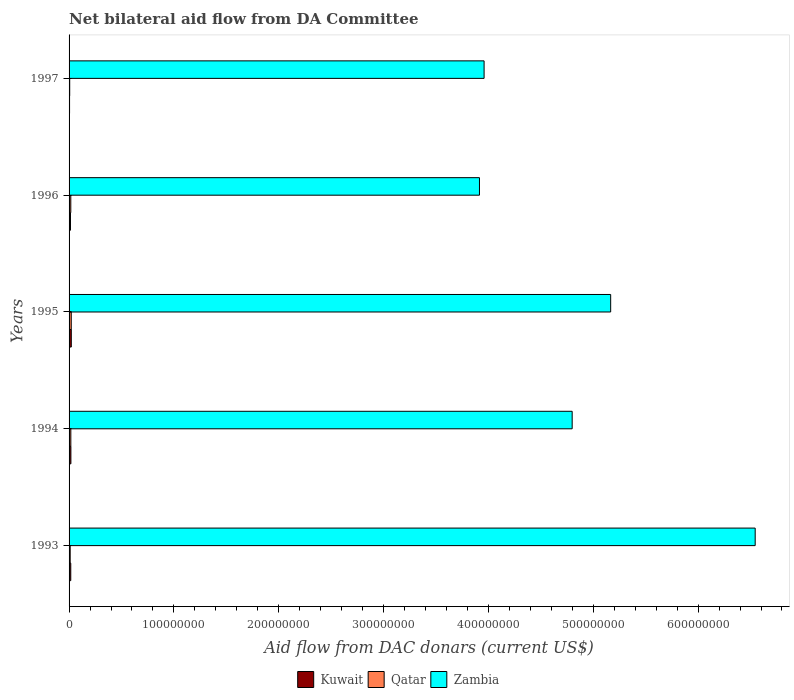How many different coloured bars are there?
Make the answer very short. 3. How many groups of bars are there?
Your response must be concise. 5. Are the number of bars per tick equal to the number of legend labels?
Your answer should be compact. Yes. Are the number of bars on each tick of the Y-axis equal?
Keep it short and to the point. Yes. How many bars are there on the 2nd tick from the top?
Provide a short and direct response. 3. What is the aid flow in in Kuwait in 1994?
Your answer should be very brief. 1.73e+06. Across all years, what is the maximum aid flow in in Qatar?
Your answer should be compact. 2.08e+06. Across all years, what is the minimum aid flow in in Zambia?
Ensure brevity in your answer.  3.91e+08. In which year was the aid flow in in Kuwait maximum?
Provide a short and direct response. 1995. What is the total aid flow in in Zambia in the graph?
Your answer should be very brief. 2.44e+09. What is the difference between the aid flow in in Kuwait in 1994 and that in 1997?
Offer a terse response. 1.26e+06. What is the difference between the aid flow in in Qatar in 1996 and the aid flow in in Kuwait in 1995?
Ensure brevity in your answer.  -4.80e+05. What is the average aid flow in in Qatar per year?
Make the answer very short. 1.41e+06. In the year 1994, what is the difference between the aid flow in in Kuwait and aid flow in in Zambia?
Your answer should be compact. -4.78e+08. In how many years, is the aid flow in in Qatar greater than 200000000 US$?
Offer a terse response. 0. What is the ratio of the aid flow in in Kuwait in 1994 to that in 1995?
Ensure brevity in your answer.  0.82. Is the aid flow in in Kuwait in 1994 less than that in 1996?
Keep it short and to the point. No. What is the difference between the highest and the lowest aid flow in in Kuwait?
Your response must be concise. 1.65e+06. What does the 1st bar from the top in 1993 represents?
Your response must be concise. Zambia. What does the 1st bar from the bottom in 1997 represents?
Provide a short and direct response. Kuwait. Is it the case that in every year, the sum of the aid flow in in Kuwait and aid flow in in Zambia is greater than the aid flow in in Qatar?
Ensure brevity in your answer.  Yes. Are all the bars in the graph horizontal?
Your answer should be compact. Yes. What is the difference between two consecutive major ticks on the X-axis?
Provide a succinct answer. 1.00e+08. Are the values on the major ticks of X-axis written in scientific E-notation?
Your response must be concise. No. Does the graph contain any zero values?
Make the answer very short. No. Does the graph contain grids?
Give a very brief answer. No. What is the title of the graph?
Ensure brevity in your answer.  Net bilateral aid flow from DA Committee. What is the label or title of the X-axis?
Keep it short and to the point. Aid flow from DAC donars (current US$). What is the label or title of the Y-axis?
Make the answer very short. Years. What is the Aid flow from DAC donars (current US$) of Kuwait in 1993?
Your answer should be compact. 1.62e+06. What is the Aid flow from DAC donars (current US$) of Qatar in 1993?
Offer a very short reply. 1.07e+06. What is the Aid flow from DAC donars (current US$) of Zambia in 1993?
Offer a terse response. 6.54e+08. What is the Aid flow from DAC donars (current US$) in Kuwait in 1994?
Offer a very short reply. 1.73e+06. What is the Aid flow from DAC donars (current US$) of Qatar in 1994?
Your answer should be compact. 1.68e+06. What is the Aid flow from DAC donars (current US$) of Zambia in 1994?
Offer a very short reply. 4.80e+08. What is the Aid flow from DAC donars (current US$) in Kuwait in 1995?
Provide a succinct answer. 2.12e+06. What is the Aid flow from DAC donars (current US$) in Qatar in 1995?
Your response must be concise. 2.08e+06. What is the Aid flow from DAC donars (current US$) of Zambia in 1995?
Keep it short and to the point. 5.17e+08. What is the Aid flow from DAC donars (current US$) of Kuwait in 1996?
Your answer should be very brief. 1.35e+06. What is the Aid flow from DAC donars (current US$) in Qatar in 1996?
Give a very brief answer. 1.64e+06. What is the Aid flow from DAC donars (current US$) of Zambia in 1996?
Your response must be concise. 3.91e+08. What is the Aid flow from DAC donars (current US$) of Kuwait in 1997?
Give a very brief answer. 4.70e+05. What is the Aid flow from DAC donars (current US$) of Zambia in 1997?
Keep it short and to the point. 3.96e+08. Across all years, what is the maximum Aid flow from DAC donars (current US$) in Kuwait?
Your answer should be very brief. 2.12e+06. Across all years, what is the maximum Aid flow from DAC donars (current US$) in Qatar?
Your answer should be very brief. 2.08e+06. Across all years, what is the maximum Aid flow from DAC donars (current US$) in Zambia?
Give a very brief answer. 6.54e+08. Across all years, what is the minimum Aid flow from DAC donars (current US$) in Qatar?
Offer a very short reply. 6.00e+05. Across all years, what is the minimum Aid flow from DAC donars (current US$) in Zambia?
Offer a terse response. 3.91e+08. What is the total Aid flow from DAC donars (current US$) of Kuwait in the graph?
Provide a short and direct response. 7.29e+06. What is the total Aid flow from DAC donars (current US$) of Qatar in the graph?
Ensure brevity in your answer.  7.07e+06. What is the total Aid flow from DAC donars (current US$) of Zambia in the graph?
Provide a succinct answer. 2.44e+09. What is the difference between the Aid flow from DAC donars (current US$) of Kuwait in 1993 and that in 1994?
Provide a short and direct response. -1.10e+05. What is the difference between the Aid flow from DAC donars (current US$) in Qatar in 1993 and that in 1994?
Ensure brevity in your answer.  -6.10e+05. What is the difference between the Aid flow from DAC donars (current US$) of Zambia in 1993 and that in 1994?
Make the answer very short. 1.75e+08. What is the difference between the Aid flow from DAC donars (current US$) of Kuwait in 1993 and that in 1995?
Your response must be concise. -5.00e+05. What is the difference between the Aid flow from DAC donars (current US$) of Qatar in 1993 and that in 1995?
Provide a succinct answer. -1.01e+06. What is the difference between the Aid flow from DAC donars (current US$) in Zambia in 1993 and that in 1995?
Make the answer very short. 1.38e+08. What is the difference between the Aid flow from DAC donars (current US$) of Kuwait in 1993 and that in 1996?
Your response must be concise. 2.70e+05. What is the difference between the Aid flow from DAC donars (current US$) of Qatar in 1993 and that in 1996?
Ensure brevity in your answer.  -5.70e+05. What is the difference between the Aid flow from DAC donars (current US$) of Zambia in 1993 and that in 1996?
Provide a succinct answer. 2.63e+08. What is the difference between the Aid flow from DAC donars (current US$) of Kuwait in 1993 and that in 1997?
Your answer should be very brief. 1.15e+06. What is the difference between the Aid flow from DAC donars (current US$) of Qatar in 1993 and that in 1997?
Give a very brief answer. 4.70e+05. What is the difference between the Aid flow from DAC donars (current US$) of Zambia in 1993 and that in 1997?
Keep it short and to the point. 2.59e+08. What is the difference between the Aid flow from DAC donars (current US$) in Kuwait in 1994 and that in 1995?
Your answer should be compact. -3.90e+05. What is the difference between the Aid flow from DAC donars (current US$) of Qatar in 1994 and that in 1995?
Give a very brief answer. -4.00e+05. What is the difference between the Aid flow from DAC donars (current US$) in Zambia in 1994 and that in 1995?
Keep it short and to the point. -3.67e+07. What is the difference between the Aid flow from DAC donars (current US$) of Kuwait in 1994 and that in 1996?
Ensure brevity in your answer.  3.80e+05. What is the difference between the Aid flow from DAC donars (current US$) of Zambia in 1994 and that in 1996?
Your response must be concise. 8.84e+07. What is the difference between the Aid flow from DAC donars (current US$) in Kuwait in 1994 and that in 1997?
Your response must be concise. 1.26e+06. What is the difference between the Aid flow from DAC donars (current US$) in Qatar in 1994 and that in 1997?
Ensure brevity in your answer.  1.08e+06. What is the difference between the Aid flow from DAC donars (current US$) of Zambia in 1994 and that in 1997?
Ensure brevity in your answer.  8.40e+07. What is the difference between the Aid flow from DAC donars (current US$) of Kuwait in 1995 and that in 1996?
Your response must be concise. 7.70e+05. What is the difference between the Aid flow from DAC donars (current US$) of Zambia in 1995 and that in 1996?
Make the answer very short. 1.25e+08. What is the difference between the Aid flow from DAC donars (current US$) in Kuwait in 1995 and that in 1997?
Provide a succinct answer. 1.65e+06. What is the difference between the Aid flow from DAC donars (current US$) of Qatar in 1995 and that in 1997?
Offer a terse response. 1.48e+06. What is the difference between the Aid flow from DAC donars (current US$) of Zambia in 1995 and that in 1997?
Keep it short and to the point. 1.21e+08. What is the difference between the Aid flow from DAC donars (current US$) in Kuwait in 1996 and that in 1997?
Offer a very short reply. 8.80e+05. What is the difference between the Aid flow from DAC donars (current US$) of Qatar in 1996 and that in 1997?
Keep it short and to the point. 1.04e+06. What is the difference between the Aid flow from DAC donars (current US$) in Zambia in 1996 and that in 1997?
Ensure brevity in your answer.  -4.41e+06. What is the difference between the Aid flow from DAC donars (current US$) of Kuwait in 1993 and the Aid flow from DAC donars (current US$) of Zambia in 1994?
Your response must be concise. -4.78e+08. What is the difference between the Aid flow from DAC donars (current US$) in Qatar in 1993 and the Aid flow from DAC donars (current US$) in Zambia in 1994?
Provide a short and direct response. -4.79e+08. What is the difference between the Aid flow from DAC donars (current US$) of Kuwait in 1993 and the Aid flow from DAC donars (current US$) of Qatar in 1995?
Ensure brevity in your answer.  -4.60e+05. What is the difference between the Aid flow from DAC donars (current US$) in Kuwait in 1993 and the Aid flow from DAC donars (current US$) in Zambia in 1995?
Your answer should be compact. -5.15e+08. What is the difference between the Aid flow from DAC donars (current US$) in Qatar in 1993 and the Aid flow from DAC donars (current US$) in Zambia in 1995?
Your answer should be very brief. -5.16e+08. What is the difference between the Aid flow from DAC donars (current US$) in Kuwait in 1993 and the Aid flow from DAC donars (current US$) in Zambia in 1996?
Give a very brief answer. -3.90e+08. What is the difference between the Aid flow from DAC donars (current US$) of Qatar in 1993 and the Aid flow from DAC donars (current US$) of Zambia in 1996?
Your answer should be compact. -3.90e+08. What is the difference between the Aid flow from DAC donars (current US$) in Kuwait in 1993 and the Aid flow from DAC donars (current US$) in Qatar in 1997?
Offer a very short reply. 1.02e+06. What is the difference between the Aid flow from DAC donars (current US$) of Kuwait in 1993 and the Aid flow from DAC donars (current US$) of Zambia in 1997?
Your answer should be compact. -3.94e+08. What is the difference between the Aid flow from DAC donars (current US$) in Qatar in 1993 and the Aid flow from DAC donars (current US$) in Zambia in 1997?
Your answer should be compact. -3.95e+08. What is the difference between the Aid flow from DAC donars (current US$) in Kuwait in 1994 and the Aid flow from DAC donars (current US$) in Qatar in 1995?
Keep it short and to the point. -3.50e+05. What is the difference between the Aid flow from DAC donars (current US$) in Kuwait in 1994 and the Aid flow from DAC donars (current US$) in Zambia in 1995?
Your response must be concise. -5.15e+08. What is the difference between the Aid flow from DAC donars (current US$) in Qatar in 1994 and the Aid flow from DAC donars (current US$) in Zambia in 1995?
Your answer should be compact. -5.15e+08. What is the difference between the Aid flow from DAC donars (current US$) in Kuwait in 1994 and the Aid flow from DAC donars (current US$) in Zambia in 1996?
Provide a succinct answer. -3.90e+08. What is the difference between the Aid flow from DAC donars (current US$) of Qatar in 1994 and the Aid flow from DAC donars (current US$) of Zambia in 1996?
Keep it short and to the point. -3.90e+08. What is the difference between the Aid flow from DAC donars (current US$) in Kuwait in 1994 and the Aid flow from DAC donars (current US$) in Qatar in 1997?
Your answer should be very brief. 1.13e+06. What is the difference between the Aid flow from DAC donars (current US$) of Kuwait in 1994 and the Aid flow from DAC donars (current US$) of Zambia in 1997?
Your answer should be very brief. -3.94e+08. What is the difference between the Aid flow from DAC donars (current US$) in Qatar in 1994 and the Aid flow from DAC donars (current US$) in Zambia in 1997?
Make the answer very short. -3.94e+08. What is the difference between the Aid flow from DAC donars (current US$) of Kuwait in 1995 and the Aid flow from DAC donars (current US$) of Zambia in 1996?
Offer a terse response. -3.89e+08. What is the difference between the Aid flow from DAC donars (current US$) in Qatar in 1995 and the Aid flow from DAC donars (current US$) in Zambia in 1996?
Give a very brief answer. -3.89e+08. What is the difference between the Aid flow from DAC donars (current US$) of Kuwait in 1995 and the Aid flow from DAC donars (current US$) of Qatar in 1997?
Provide a succinct answer. 1.52e+06. What is the difference between the Aid flow from DAC donars (current US$) in Kuwait in 1995 and the Aid flow from DAC donars (current US$) in Zambia in 1997?
Provide a short and direct response. -3.94e+08. What is the difference between the Aid flow from DAC donars (current US$) in Qatar in 1995 and the Aid flow from DAC donars (current US$) in Zambia in 1997?
Your answer should be compact. -3.94e+08. What is the difference between the Aid flow from DAC donars (current US$) of Kuwait in 1996 and the Aid flow from DAC donars (current US$) of Qatar in 1997?
Offer a very short reply. 7.50e+05. What is the difference between the Aid flow from DAC donars (current US$) of Kuwait in 1996 and the Aid flow from DAC donars (current US$) of Zambia in 1997?
Ensure brevity in your answer.  -3.95e+08. What is the difference between the Aid flow from DAC donars (current US$) of Qatar in 1996 and the Aid flow from DAC donars (current US$) of Zambia in 1997?
Offer a very short reply. -3.94e+08. What is the average Aid flow from DAC donars (current US$) of Kuwait per year?
Your answer should be very brief. 1.46e+06. What is the average Aid flow from DAC donars (current US$) of Qatar per year?
Offer a terse response. 1.41e+06. What is the average Aid flow from DAC donars (current US$) of Zambia per year?
Your answer should be very brief. 4.88e+08. In the year 1993, what is the difference between the Aid flow from DAC donars (current US$) in Kuwait and Aid flow from DAC donars (current US$) in Qatar?
Offer a terse response. 5.50e+05. In the year 1993, what is the difference between the Aid flow from DAC donars (current US$) of Kuwait and Aid flow from DAC donars (current US$) of Zambia?
Provide a short and direct response. -6.53e+08. In the year 1993, what is the difference between the Aid flow from DAC donars (current US$) in Qatar and Aid flow from DAC donars (current US$) in Zambia?
Offer a terse response. -6.53e+08. In the year 1994, what is the difference between the Aid flow from DAC donars (current US$) of Kuwait and Aid flow from DAC donars (current US$) of Zambia?
Offer a very short reply. -4.78e+08. In the year 1994, what is the difference between the Aid flow from DAC donars (current US$) in Qatar and Aid flow from DAC donars (current US$) in Zambia?
Offer a terse response. -4.78e+08. In the year 1995, what is the difference between the Aid flow from DAC donars (current US$) of Kuwait and Aid flow from DAC donars (current US$) of Qatar?
Offer a terse response. 4.00e+04. In the year 1995, what is the difference between the Aid flow from DAC donars (current US$) of Kuwait and Aid flow from DAC donars (current US$) of Zambia?
Your answer should be compact. -5.14e+08. In the year 1995, what is the difference between the Aid flow from DAC donars (current US$) of Qatar and Aid flow from DAC donars (current US$) of Zambia?
Provide a short and direct response. -5.15e+08. In the year 1996, what is the difference between the Aid flow from DAC donars (current US$) in Kuwait and Aid flow from DAC donars (current US$) in Qatar?
Give a very brief answer. -2.90e+05. In the year 1996, what is the difference between the Aid flow from DAC donars (current US$) of Kuwait and Aid flow from DAC donars (current US$) of Zambia?
Your response must be concise. -3.90e+08. In the year 1996, what is the difference between the Aid flow from DAC donars (current US$) in Qatar and Aid flow from DAC donars (current US$) in Zambia?
Provide a succinct answer. -3.90e+08. In the year 1997, what is the difference between the Aid flow from DAC donars (current US$) in Kuwait and Aid flow from DAC donars (current US$) in Zambia?
Offer a very short reply. -3.95e+08. In the year 1997, what is the difference between the Aid flow from DAC donars (current US$) in Qatar and Aid flow from DAC donars (current US$) in Zambia?
Your response must be concise. -3.95e+08. What is the ratio of the Aid flow from DAC donars (current US$) in Kuwait in 1993 to that in 1994?
Ensure brevity in your answer.  0.94. What is the ratio of the Aid flow from DAC donars (current US$) of Qatar in 1993 to that in 1994?
Your response must be concise. 0.64. What is the ratio of the Aid flow from DAC donars (current US$) of Zambia in 1993 to that in 1994?
Make the answer very short. 1.36. What is the ratio of the Aid flow from DAC donars (current US$) of Kuwait in 1993 to that in 1995?
Make the answer very short. 0.76. What is the ratio of the Aid flow from DAC donars (current US$) in Qatar in 1993 to that in 1995?
Give a very brief answer. 0.51. What is the ratio of the Aid flow from DAC donars (current US$) in Zambia in 1993 to that in 1995?
Keep it short and to the point. 1.27. What is the ratio of the Aid flow from DAC donars (current US$) of Qatar in 1993 to that in 1996?
Offer a terse response. 0.65. What is the ratio of the Aid flow from DAC donars (current US$) in Zambia in 1993 to that in 1996?
Provide a succinct answer. 1.67. What is the ratio of the Aid flow from DAC donars (current US$) in Kuwait in 1993 to that in 1997?
Ensure brevity in your answer.  3.45. What is the ratio of the Aid flow from DAC donars (current US$) in Qatar in 1993 to that in 1997?
Ensure brevity in your answer.  1.78. What is the ratio of the Aid flow from DAC donars (current US$) of Zambia in 1993 to that in 1997?
Offer a terse response. 1.65. What is the ratio of the Aid flow from DAC donars (current US$) in Kuwait in 1994 to that in 1995?
Keep it short and to the point. 0.82. What is the ratio of the Aid flow from DAC donars (current US$) of Qatar in 1994 to that in 1995?
Provide a short and direct response. 0.81. What is the ratio of the Aid flow from DAC donars (current US$) of Zambia in 1994 to that in 1995?
Your response must be concise. 0.93. What is the ratio of the Aid flow from DAC donars (current US$) of Kuwait in 1994 to that in 1996?
Give a very brief answer. 1.28. What is the ratio of the Aid flow from DAC donars (current US$) in Qatar in 1994 to that in 1996?
Provide a succinct answer. 1.02. What is the ratio of the Aid flow from DAC donars (current US$) of Zambia in 1994 to that in 1996?
Your response must be concise. 1.23. What is the ratio of the Aid flow from DAC donars (current US$) of Kuwait in 1994 to that in 1997?
Ensure brevity in your answer.  3.68. What is the ratio of the Aid flow from DAC donars (current US$) of Zambia in 1994 to that in 1997?
Your response must be concise. 1.21. What is the ratio of the Aid flow from DAC donars (current US$) in Kuwait in 1995 to that in 1996?
Offer a very short reply. 1.57. What is the ratio of the Aid flow from DAC donars (current US$) in Qatar in 1995 to that in 1996?
Your answer should be very brief. 1.27. What is the ratio of the Aid flow from DAC donars (current US$) of Zambia in 1995 to that in 1996?
Provide a succinct answer. 1.32. What is the ratio of the Aid flow from DAC donars (current US$) of Kuwait in 1995 to that in 1997?
Your answer should be compact. 4.51. What is the ratio of the Aid flow from DAC donars (current US$) in Qatar in 1995 to that in 1997?
Your response must be concise. 3.47. What is the ratio of the Aid flow from DAC donars (current US$) in Zambia in 1995 to that in 1997?
Provide a succinct answer. 1.3. What is the ratio of the Aid flow from DAC donars (current US$) of Kuwait in 1996 to that in 1997?
Give a very brief answer. 2.87. What is the ratio of the Aid flow from DAC donars (current US$) in Qatar in 1996 to that in 1997?
Ensure brevity in your answer.  2.73. What is the ratio of the Aid flow from DAC donars (current US$) of Zambia in 1996 to that in 1997?
Offer a very short reply. 0.99. What is the difference between the highest and the second highest Aid flow from DAC donars (current US$) in Kuwait?
Provide a succinct answer. 3.90e+05. What is the difference between the highest and the second highest Aid flow from DAC donars (current US$) of Qatar?
Your answer should be compact. 4.00e+05. What is the difference between the highest and the second highest Aid flow from DAC donars (current US$) in Zambia?
Ensure brevity in your answer.  1.38e+08. What is the difference between the highest and the lowest Aid flow from DAC donars (current US$) of Kuwait?
Keep it short and to the point. 1.65e+06. What is the difference between the highest and the lowest Aid flow from DAC donars (current US$) in Qatar?
Provide a succinct answer. 1.48e+06. What is the difference between the highest and the lowest Aid flow from DAC donars (current US$) of Zambia?
Provide a short and direct response. 2.63e+08. 